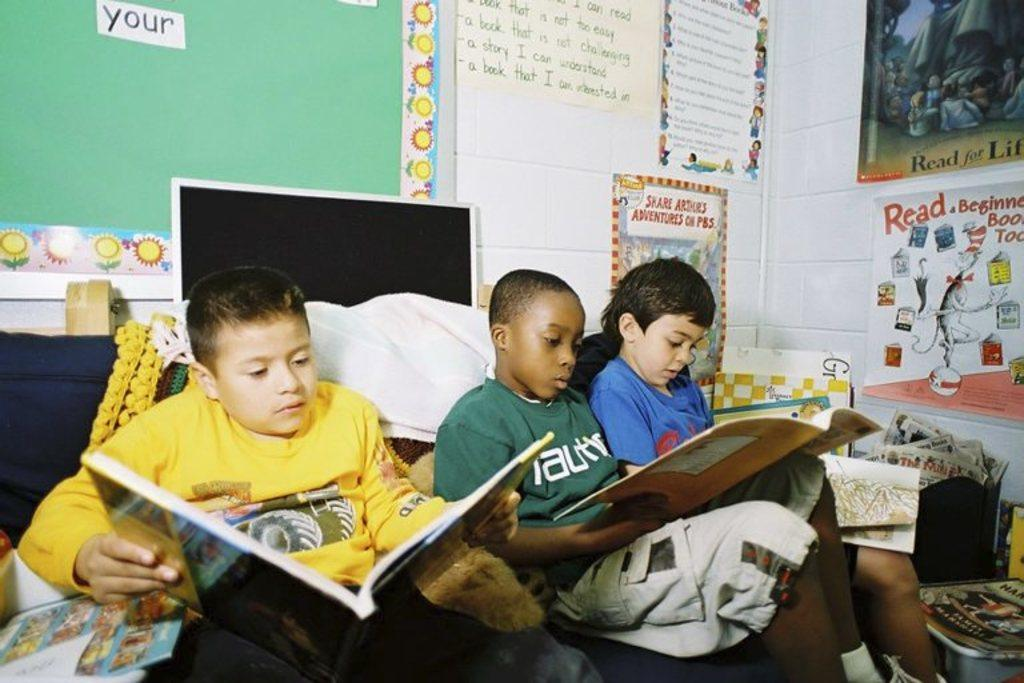<image>
Share a concise interpretation of the image provided. three boys read with a your sign on the board behind them 